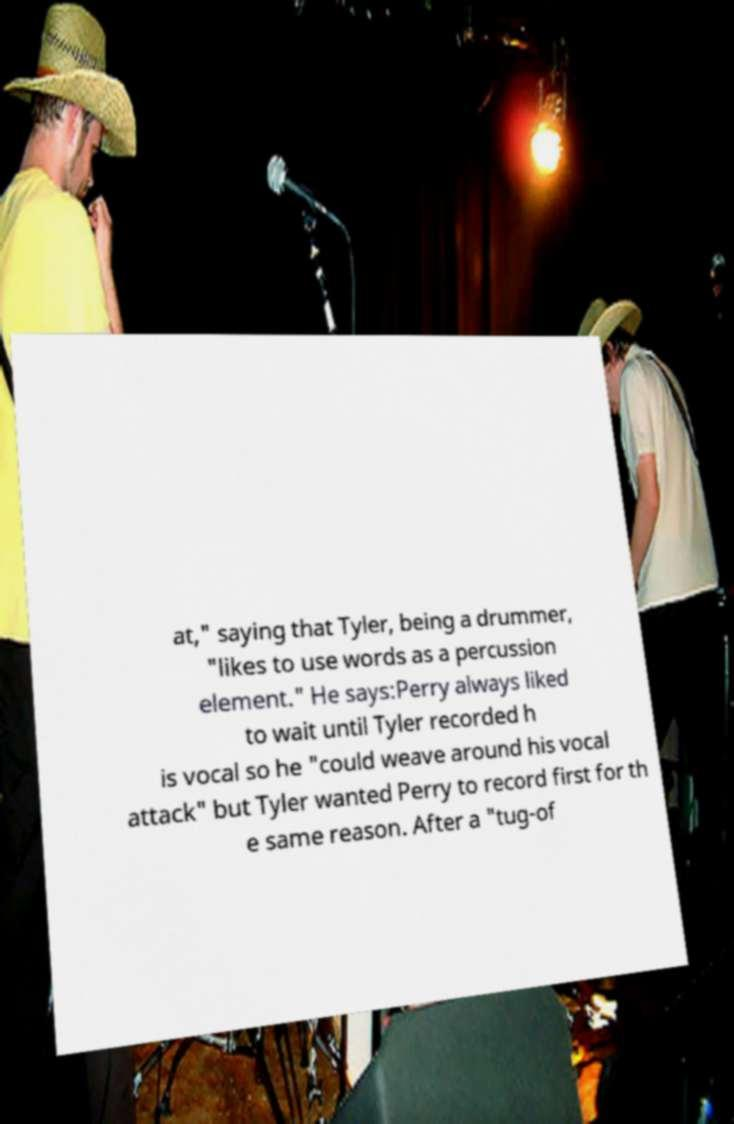For documentation purposes, I need the text within this image transcribed. Could you provide that? at," saying that Tyler, being a drummer, "likes to use words as a percussion element." He says:Perry always liked to wait until Tyler recorded h is vocal so he "could weave around his vocal attack" but Tyler wanted Perry to record first for th e same reason. After a "tug-of 